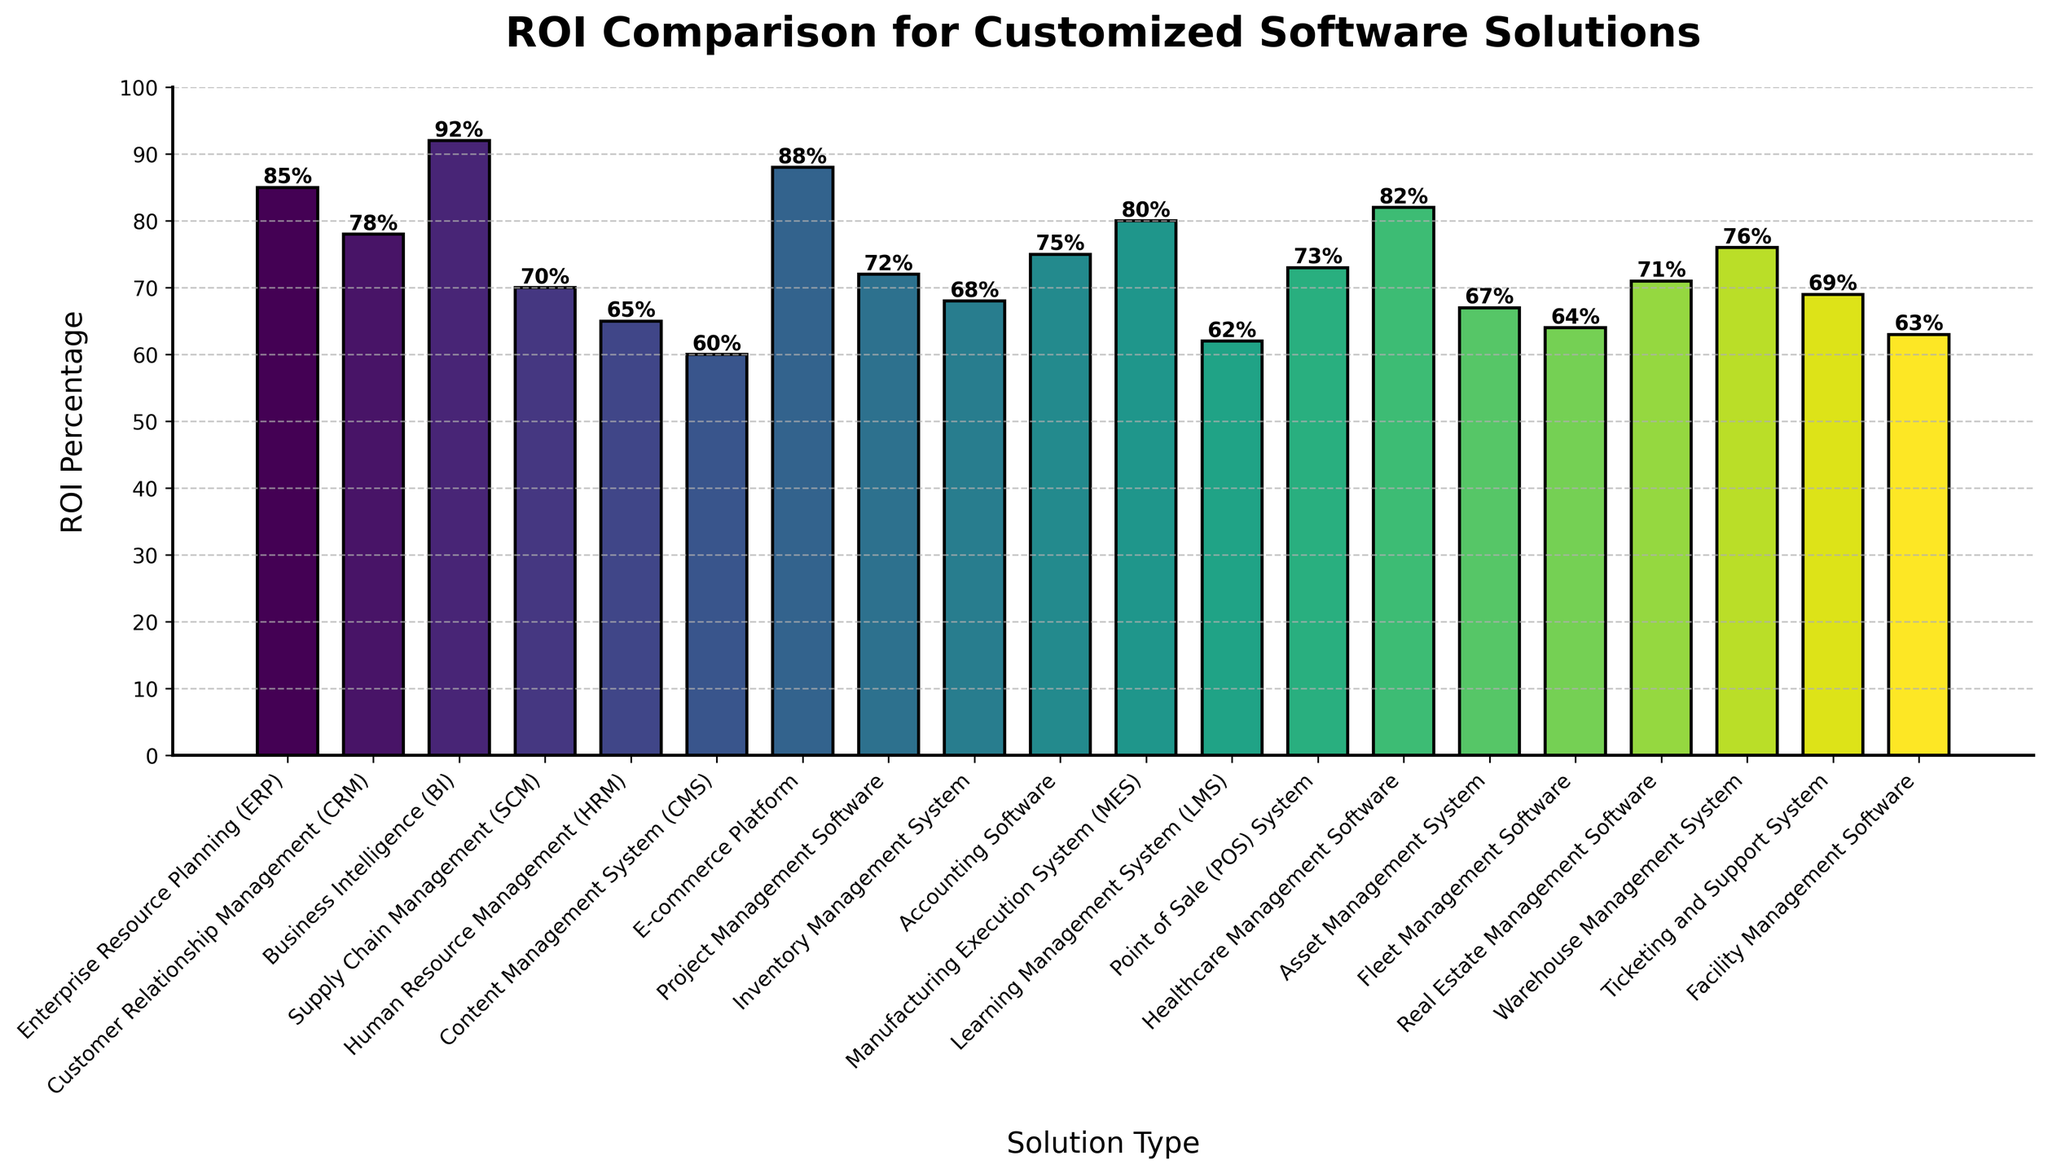What type of software solution has the highest ROI percentage? The bar representing Business Intelligence (BI) shows the highest height, indicating it has the highest ROI percentage.
Answer: Business Intelligence (BI) Which type of software solution has a higher ROI: Customer Relationship Management (CRM) or Warehouse Management System (WMS)? The height of the CRM bar is higher than the WMS bar, indicating a higher ROI percentage for CRM.
Answer: Customer Relationship Management (CRM) What is the difference in ROI percentage between the highest and lowest listed solutions? The highest ROI is BI at 92%, and the lowest is CMS at 60%. The difference is 92% - 60% = 32%.
Answer: 32% Which software solutions have an ROI higher than 80%? The bars for BI, ERP, Healthcare Management Software, and E-commerce Platform are higher than the 80% mark on the y-axis.
Answer: Business Intelligence (BI), Enterprise Resource Planning (ERP), Healthcare Management Software, E-commerce Platform What is the average ROI percentage for Project Management Software, Inventory Management System, and Fleet Management Software? The ROI percentages for these are 72%, 68%, and 64%. The average is (72 + 68 + 64) / 3 = 68%.
Answer: 68% How many software solutions have an ROI of 70% or above? Counting the bars with ROI percentages of 70% or above shows there are 12 solutions.
Answer: 12 Which type of software has a lower ROI: Facility Management Software or Asset Management System? The bar for Facility Management Software is lower than the bar for Asset Management System, indicating a lower ROI percentage.
Answer: Facility Management Software What is the median ROI percentage among all the listed software solutions? To find the median, list the ROI values in order from lowest to highest: 60, 62, 63, 64, 65, 67, 68, 69, 70, 71, 72, 73, 75, 76, 78, 80, 82, 85, 88, 92. Since there are 20 values, the median is the average of the 10th and 11th values: (71 + 72) / 2 = 71.5.
Answer: 71.5 Which solutions have an ROI less than 65%? The bars representing CMS, Learning Management System (LMS), Facility Management Software, and Fleet Management Software are below the 65% mark on the y-axis.
Answer: Content Management System (CMS), Learning Management System (LMS), Facility Management Software, Fleet Management Software What is the sum of the ROI percentages for ERP, CRM, and SCM? The ROI percentages for these are 85%, 78%, and 70%. The sum is 85 + 78 + 70 = 233%.
Answer: 233% 